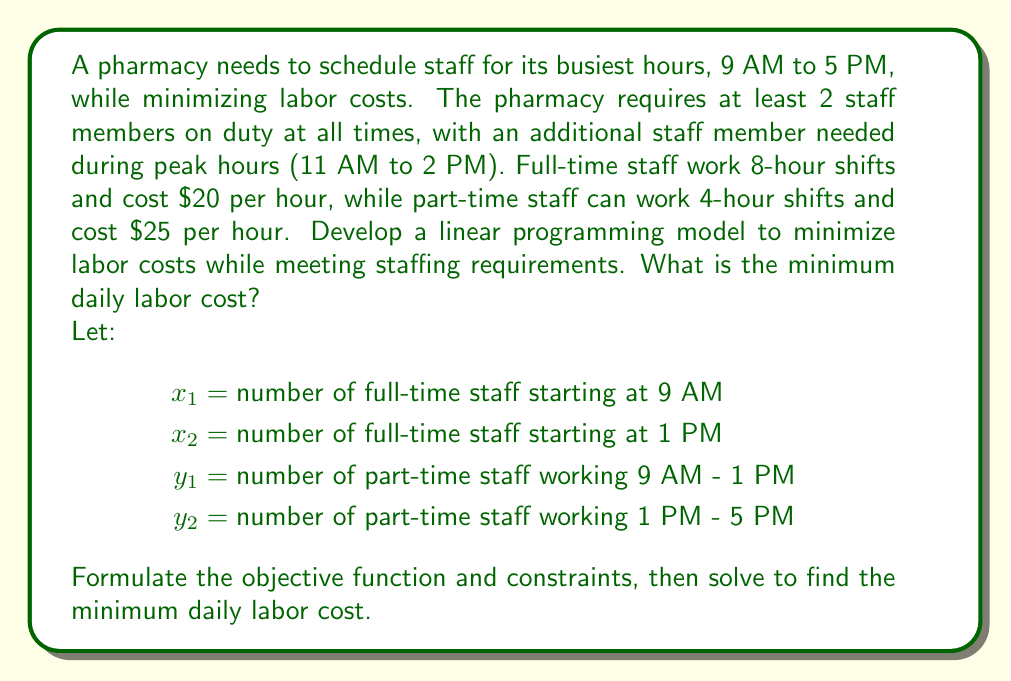Provide a solution to this math problem. To solve this problem, we'll follow these steps:

1. Formulate the objective function
2. Identify and formulate the constraints
3. Solve the linear programming problem

Step 1: Objective function

We want to minimize the total labor cost:

$$ \text{Minimize } Z = 160x_1 + 160x_2 + 100y_1 + 100y_2 $$

Step 2: Constraints

a) Staffing requirements for each time slot:
   9 AM - 11 AM: $x_1 + y_1 \geq 2$
   11 AM - 1 PM: $x_1 + y_1 \geq 3$
   1 PM - 2 PM: $x_1 + x_2 + y_2 \geq 3$
   2 PM - 5 PM: $x_2 + y_2 \geq 2$

b) Non-negativity constraints:
   $x_1, x_2, y_1, y_2 \geq 0$

Step 3: Solving the linear programming problem

We can solve this using the simplex method or linear programming software. The optimal solution is:

$x_1 = 2, x_2 = 1, y_1 = 1, y_2 = 0$

This means:
- 2 full-time staff start at 9 AM
- 1 full-time staff starts at 1 PM
- 1 part-time staff works from 9 AM to 1 PM
- No part-time staff is needed from 1 PM to 5 PM

Calculating the minimum daily labor cost:

$$ Z = 160(2) + 160(1) + 100(1) + 100(0) = 580 $$
Answer: The minimum daily labor cost is $580. 